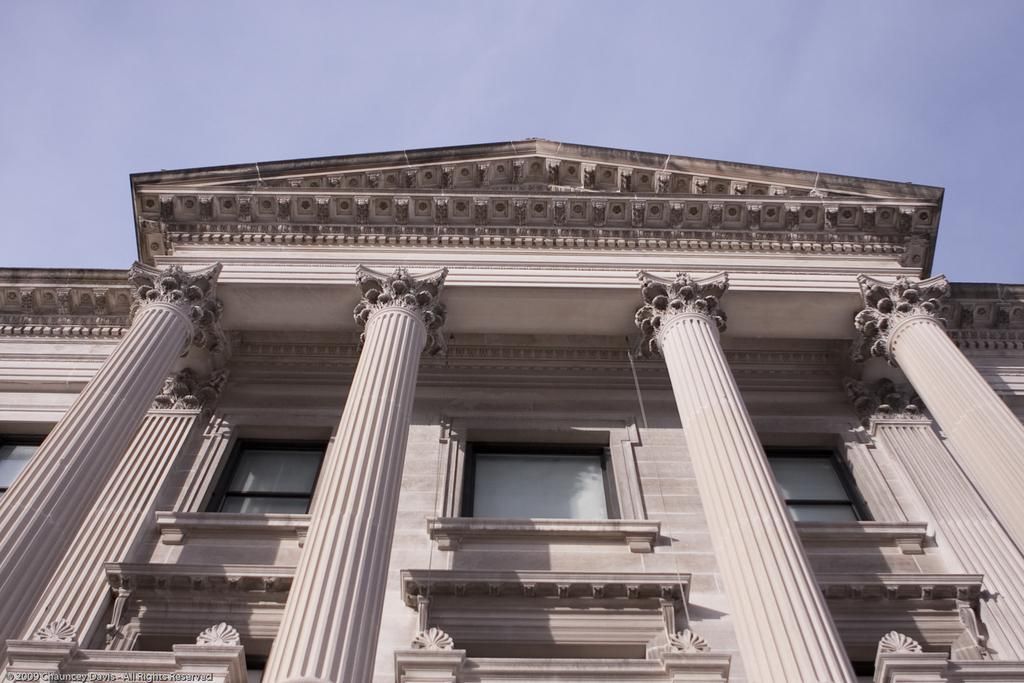What type of structure is visible in the image? There is a building in the image. What architectural feature can be seen in front of the building? There are pillars in front of the building. What type of stitch is used to hold the building together in the image? The image does not provide information about the type of stitch used to hold the building together, as buildings are typically constructed using materials like concrete, steel, or wood. 